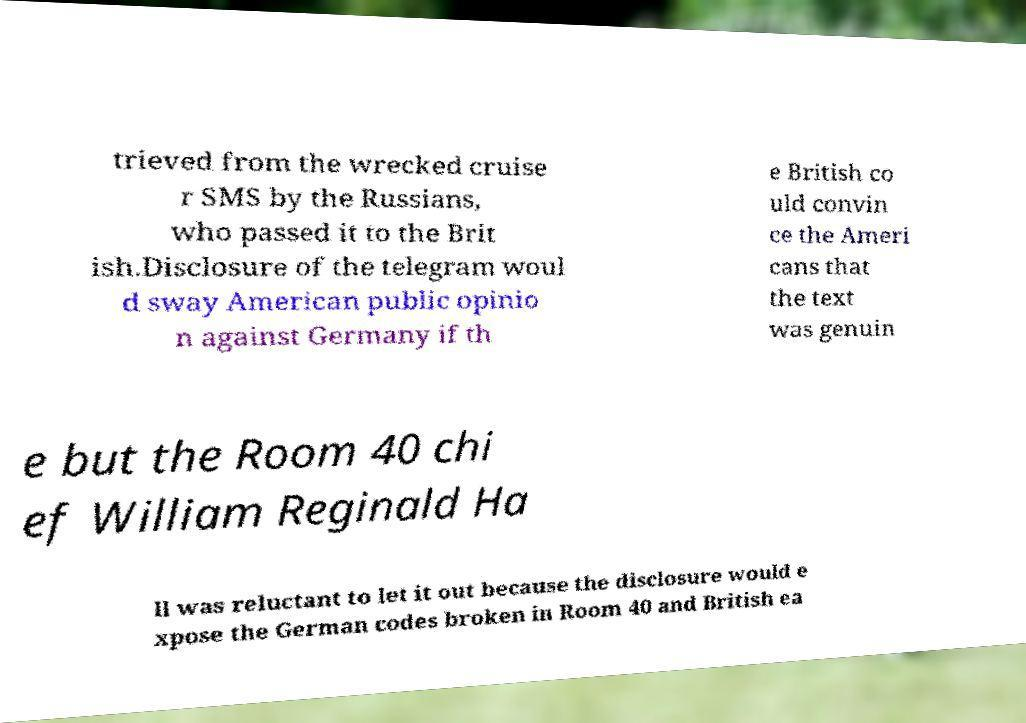Can you read and provide the text displayed in the image?This photo seems to have some interesting text. Can you extract and type it out for me? trieved from the wrecked cruise r SMS by the Russians, who passed it to the Brit ish.Disclosure of the telegram woul d sway American public opinio n against Germany if th e British co uld convin ce the Ameri cans that the text was genuin e but the Room 40 chi ef William Reginald Ha ll was reluctant to let it out because the disclosure would e xpose the German codes broken in Room 40 and British ea 